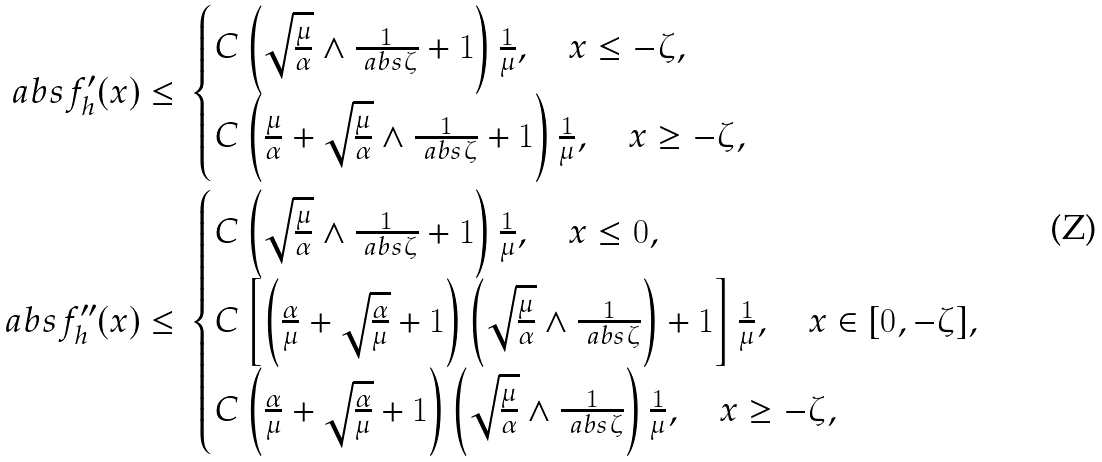Convert formula to latex. <formula><loc_0><loc_0><loc_500><loc_500>\ a b s { f _ { h } ^ { \prime } ( x ) } \leq & \ \begin{cases} C \left ( \sqrt { \frac { \mu } { \alpha } } \wedge \frac { 1 } { \ a b s { \zeta } } + 1 \right ) \frac { 1 } { \mu } , \quad x \leq - \zeta , \\ C \left ( \frac { \mu } { \alpha } + \sqrt { \frac { \mu } { \alpha } } \wedge \frac { 1 } { \ a b s { \zeta } } + 1 \right ) \frac { 1 } { \mu } , \quad x \geq - \zeta , \end{cases} \\ \ a b s { f _ { h } ^ { \prime \prime } ( x ) } \leq & \ \begin{cases} C \left ( \sqrt { \frac { \mu } { \alpha } } \wedge \frac { 1 } { \ a b s { \zeta } } + 1 \right ) \frac { 1 } { \mu } , \quad x \leq 0 , \\ C \left [ \left ( \frac { \alpha } { \mu } + \sqrt { \frac { \alpha } { \mu } } + 1 \right ) \left ( \sqrt { \frac { \mu } { \alpha } } \wedge \frac { 1 } { \ a b s { \zeta } } \right ) + 1 \right ] \frac { 1 } { \mu } , \quad x \in [ 0 , - \zeta ] , \\ C \left ( \frac { \alpha } { \mu } + \sqrt { \frac { \alpha } { \mu } } + 1 \right ) \left ( \sqrt { \frac { \mu } { \alpha } } \wedge \frac { 1 } { \ a b s { \zeta } } \right ) \frac { 1 } { \mu } , \quad x \geq - \zeta , \end{cases} \\</formula> 